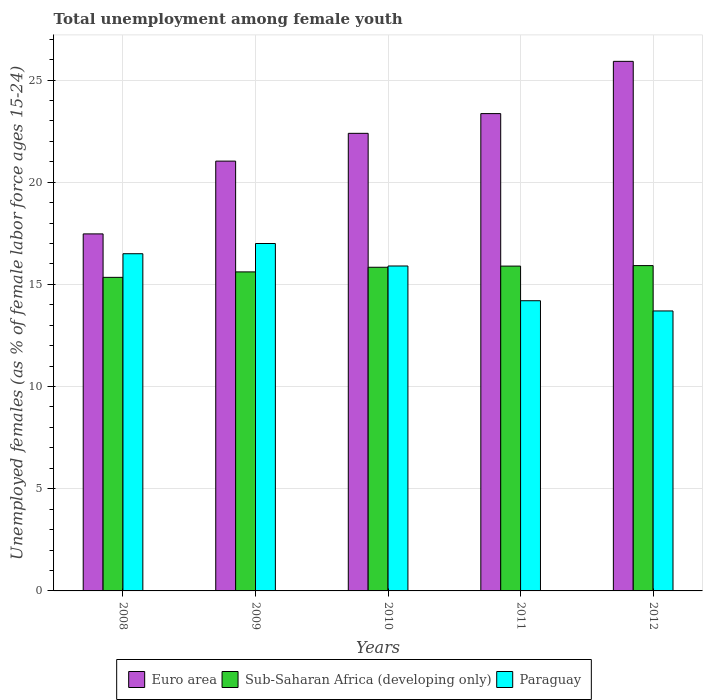What is the label of the 1st group of bars from the left?
Give a very brief answer. 2008. What is the percentage of unemployed females in in Paraguay in 2010?
Offer a terse response. 15.9. Across all years, what is the maximum percentage of unemployed females in in Paraguay?
Provide a short and direct response. 17. Across all years, what is the minimum percentage of unemployed females in in Paraguay?
Keep it short and to the point. 13.7. In which year was the percentage of unemployed females in in Euro area maximum?
Offer a very short reply. 2012. In which year was the percentage of unemployed females in in Sub-Saharan Africa (developing only) minimum?
Your response must be concise. 2008. What is the total percentage of unemployed females in in Sub-Saharan Africa (developing only) in the graph?
Your response must be concise. 78.61. What is the difference between the percentage of unemployed females in in Sub-Saharan Africa (developing only) in 2008 and that in 2010?
Keep it short and to the point. -0.49. What is the difference between the percentage of unemployed females in in Sub-Saharan Africa (developing only) in 2011 and the percentage of unemployed females in in Euro area in 2009?
Provide a short and direct response. -5.14. What is the average percentage of unemployed females in in Sub-Saharan Africa (developing only) per year?
Offer a very short reply. 15.72. In the year 2011, what is the difference between the percentage of unemployed females in in Paraguay and percentage of unemployed females in in Euro area?
Keep it short and to the point. -9.16. In how many years, is the percentage of unemployed females in in Euro area greater than 22 %?
Keep it short and to the point. 3. What is the ratio of the percentage of unemployed females in in Euro area in 2009 to that in 2011?
Provide a succinct answer. 0.9. Is the difference between the percentage of unemployed females in in Paraguay in 2008 and 2012 greater than the difference between the percentage of unemployed females in in Euro area in 2008 and 2012?
Keep it short and to the point. Yes. What is the difference between the highest and the lowest percentage of unemployed females in in Sub-Saharan Africa (developing only)?
Ensure brevity in your answer.  0.57. What does the 2nd bar from the right in 2010 represents?
Your answer should be compact. Sub-Saharan Africa (developing only). Are all the bars in the graph horizontal?
Give a very brief answer. No. What is the difference between two consecutive major ticks on the Y-axis?
Offer a very short reply. 5. How many legend labels are there?
Provide a succinct answer. 3. What is the title of the graph?
Offer a terse response. Total unemployment among female youth. Does "Philippines" appear as one of the legend labels in the graph?
Offer a very short reply. No. What is the label or title of the Y-axis?
Keep it short and to the point. Unemployed females (as % of female labor force ages 15-24). What is the Unemployed females (as % of female labor force ages 15-24) of Euro area in 2008?
Make the answer very short. 17.47. What is the Unemployed females (as % of female labor force ages 15-24) of Sub-Saharan Africa (developing only) in 2008?
Provide a succinct answer. 15.34. What is the Unemployed females (as % of female labor force ages 15-24) of Paraguay in 2008?
Your answer should be compact. 16.5. What is the Unemployed females (as % of female labor force ages 15-24) of Euro area in 2009?
Make the answer very short. 21.03. What is the Unemployed females (as % of female labor force ages 15-24) of Sub-Saharan Africa (developing only) in 2009?
Your answer should be very brief. 15.61. What is the Unemployed females (as % of female labor force ages 15-24) of Euro area in 2010?
Offer a very short reply. 22.39. What is the Unemployed females (as % of female labor force ages 15-24) of Sub-Saharan Africa (developing only) in 2010?
Offer a very short reply. 15.84. What is the Unemployed females (as % of female labor force ages 15-24) of Paraguay in 2010?
Your response must be concise. 15.9. What is the Unemployed females (as % of female labor force ages 15-24) of Euro area in 2011?
Provide a succinct answer. 23.36. What is the Unemployed females (as % of female labor force ages 15-24) in Sub-Saharan Africa (developing only) in 2011?
Ensure brevity in your answer.  15.89. What is the Unemployed females (as % of female labor force ages 15-24) in Paraguay in 2011?
Provide a short and direct response. 14.2. What is the Unemployed females (as % of female labor force ages 15-24) of Euro area in 2012?
Provide a succinct answer. 25.91. What is the Unemployed females (as % of female labor force ages 15-24) in Sub-Saharan Africa (developing only) in 2012?
Offer a terse response. 15.92. What is the Unemployed females (as % of female labor force ages 15-24) of Paraguay in 2012?
Make the answer very short. 13.7. Across all years, what is the maximum Unemployed females (as % of female labor force ages 15-24) in Euro area?
Give a very brief answer. 25.91. Across all years, what is the maximum Unemployed females (as % of female labor force ages 15-24) in Sub-Saharan Africa (developing only)?
Offer a terse response. 15.92. Across all years, what is the minimum Unemployed females (as % of female labor force ages 15-24) of Euro area?
Ensure brevity in your answer.  17.47. Across all years, what is the minimum Unemployed females (as % of female labor force ages 15-24) of Sub-Saharan Africa (developing only)?
Offer a terse response. 15.34. Across all years, what is the minimum Unemployed females (as % of female labor force ages 15-24) of Paraguay?
Offer a terse response. 13.7. What is the total Unemployed females (as % of female labor force ages 15-24) in Euro area in the graph?
Your answer should be very brief. 110.16. What is the total Unemployed females (as % of female labor force ages 15-24) in Sub-Saharan Africa (developing only) in the graph?
Give a very brief answer. 78.61. What is the total Unemployed females (as % of female labor force ages 15-24) in Paraguay in the graph?
Keep it short and to the point. 77.3. What is the difference between the Unemployed females (as % of female labor force ages 15-24) of Euro area in 2008 and that in 2009?
Offer a terse response. -3.56. What is the difference between the Unemployed females (as % of female labor force ages 15-24) of Sub-Saharan Africa (developing only) in 2008 and that in 2009?
Ensure brevity in your answer.  -0.27. What is the difference between the Unemployed females (as % of female labor force ages 15-24) of Paraguay in 2008 and that in 2009?
Offer a terse response. -0.5. What is the difference between the Unemployed females (as % of female labor force ages 15-24) in Euro area in 2008 and that in 2010?
Your answer should be compact. -4.92. What is the difference between the Unemployed females (as % of female labor force ages 15-24) in Sub-Saharan Africa (developing only) in 2008 and that in 2010?
Provide a short and direct response. -0.49. What is the difference between the Unemployed females (as % of female labor force ages 15-24) of Paraguay in 2008 and that in 2010?
Provide a short and direct response. 0.6. What is the difference between the Unemployed females (as % of female labor force ages 15-24) in Euro area in 2008 and that in 2011?
Ensure brevity in your answer.  -5.89. What is the difference between the Unemployed females (as % of female labor force ages 15-24) of Sub-Saharan Africa (developing only) in 2008 and that in 2011?
Your answer should be compact. -0.55. What is the difference between the Unemployed females (as % of female labor force ages 15-24) of Paraguay in 2008 and that in 2011?
Your answer should be compact. 2.3. What is the difference between the Unemployed females (as % of female labor force ages 15-24) of Euro area in 2008 and that in 2012?
Give a very brief answer. -8.44. What is the difference between the Unemployed females (as % of female labor force ages 15-24) in Sub-Saharan Africa (developing only) in 2008 and that in 2012?
Keep it short and to the point. -0.57. What is the difference between the Unemployed females (as % of female labor force ages 15-24) in Euro area in 2009 and that in 2010?
Keep it short and to the point. -1.36. What is the difference between the Unemployed females (as % of female labor force ages 15-24) in Sub-Saharan Africa (developing only) in 2009 and that in 2010?
Your answer should be compact. -0.23. What is the difference between the Unemployed females (as % of female labor force ages 15-24) in Euro area in 2009 and that in 2011?
Offer a terse response. -2.33. What is the difference between the Unemployed females (as % of female labor force ages 15-24) in Sub-Saharan Africa (developing only) in 2009 and that in 2011?
Provide a short and direct response. -0.28. What is the difference between the Unemployed females (as % of female labor force ages 15-24) of Paraguay in 2009 and that in 2011?
Offer a very short reply. 2.8. What is the difference between the Unemployed females (as % of female labor force ages 15-24) in Euro area in 2009 and that in 2012?
Provide a short and direct response. -4.88. What is the difference between the Unemployed females (as % of female labor force ages 15-24) of Sub-Saharan Africa (developing only) in 2009 and that in 2012?
Ensure brevity in your answer.  -0.31. What is the difference between the Unemployed females (as % of female labor force ages 15-24) in Euro area in 2010 and that in 2011?
Provide a short and direct response. -0.97. What is the difference between the Unemployed females (as % of female labor force ages 15-24) in Sub-Saharan Africa (developing only) in 2010 and that in 2011?
Give a very brief answer. -0.06. What is the difference between the Unemployed females (as % of female labor force ages 15-24) of Paraguay in 2010 and that in 2011?
Your answer should be very brief. 1.7. What is the difference between the Unemployed females (as % of female labor force ages 15-24) in Euro area in 2010 and that in 2012?
Ensure brevity in your answer.  -3.52. What is the difference between the Unemployed females (as % of female labor force ages 15-24) of Sub-Saharan Africa (developing only) in 2010 and that in 2012?
Make the answer very short. -0.08. What is the difference between the Unemployed females (as % of female labor force ages 15-24) of Euro area in 2011 and that in 2012?
Your answer should be very brief. -2.56. What is the difference between the Unemployed females (as % of female labor force ages 15-24) in Sub-Saharan Africa (developing only) in 2011 and that in 2012?
Provide a succinct answer. -0.02. What is the difference between the Unemployed females (as % of female labor force ages 15-24) in Paraguay in 2011 and that in 2012?
Your answer should be compact. 0.5. What is the difference between the Unemployed females (as % of female labor force ages 15-24) in Euro area in 2008 and the Unemployed females (as % of female labor force ages 15-24) in Sub-Saharan Africa (developing only) in 2009?
Ensure brevity in your answer.  1.86. What is the difference between the Unemployed females (as % of female labor force ages 15-24) in Euro area in 2008 and the Unemployed females (as % of female labor force ages 15-24) in Paraguay in 2009?
Offer a very short reply. 0.47. What is the difference between the Unemployed females (as % of female labor force ages 15-24) of Sub-Saharan Africa (developing only) in 2008 and the Unemployed females (as % of female labor force ages 15-24) of Paraguay in 2009?
Your response must be concise. -1.66. What is the difference between the Unemployed females (as % of female labor force ages 15-24) in Euro area in 2008 and the Unemployed females (as % of female labor force ages 15-24) in Sub-Saharan Africa (developing only) in 2010?
Your response must be concise. 1.63. What is the difference between the Unemployed females (as % of female labor force ages 15-24) in Euro area in 2008 and the Unemployed females (as % of female labor force ages 15-24) in Paraguay in 2010?
Make the answer very short. 1.57. What is the difference between the Unemployed females (as % of female labor force ages 15-24) in Sub-Saharan Africa (developing only) in 2008 and the Unemployed females (as % of female labor force ages 15-24) in Paraguay in 2010?
Provide a succinct answer. -0.56. What is the difference between the Unemployed females (as % of female labor force ages 15-24) in Euro area in 2008 and the Unemployed females (as % of female labor force ages 15-24) in Sub-Saharan Africa (developing only) in 2011?
Provide a short and direct response. 1.58. What is the difference between the Unemployed females (as % of female labor force ages 15-24) in Euro area in 2008 and the Unemployed females (as % of female labor force ages 15-24) in Paraguay in 2011?
Your response must be concise. 3.27. What is the difference between the Unemployed females (as % of female labor force ages 15-24) in Sub-Saharan Africa (developing only) in 2008 and the Unemployed females (as % of female labor force ages 15-24) in Paraguay in 2011?
Offer a terse response. 1.14. What is the difference between the Unemployed females (as % of female labor force ages 15-24) in Euro area in 2008 and the Unemployed females (as % of female labor force ages 15-24) in Sub-Saharan Africa (developing only) in 2012?
Your answer should be compact. 1.55. What is the difference between the Unemployed females (as % of female labor force ages 15-24) in Euro area in 2008 and the Unemployed females (as % of female labor force ages 15-24) in Paraguay in 2012?
Keep it short and to the point. 3.77. What is the difference between the Unemployed females (as % of female labor force ages 15-24) of Sub-Saharan Africa (developing only) in 2008 and the Unemployed females (as % of female labor force ages 15-24) of Paraguay in 2012?
Provide a succinct answer. 1.64. What is the difference between the Unemployed females (as % of female labor force ages 15-24) of Euro area in 2009 and the Unemployed females (as % of female labor force ages 15-24) of Sub-Saharan Africa (developing only) in 2010?
Your answer should be very brief. 5.19. What is the difference between the Unemployed females (as % of female labor force ages 15-24) in Euro area in 2009 and the Unemployed females (as % of female labor force ages 15-24) in Paraguay in 2010?
Provide a short and direct response. 5.13. What is the difference between the Unemployed females (as % of female labor force ages 15-24) of Sub-Saharan Africa (developing only) in 2009 and the Unemployed females (as % of female labor force ages 15-24) of Paraguay in 2010?
Ensure brevity in your answer.  -0.29. What is the difference between the Unemployed females (as % of female labor force ages 15-24) of Euro area in 2009 and the Unemployed females (as % of female labor force ages 15-24) of Sub-Saharan Africa (developing only) in 2011?
Keep it short and to the point. 5.14. What is the difference between the Unemployed females (as % of female labor force ages 15-24) in Euro area in 2009 and the Unemployed females (as % of female labor force ages 15-24) in Paraguay in 2011?
Offer a terse response. 6.83. What is the difference between the Unemployed females (as % of female labor force ages 15-24) in Sub-Saharan Africa (developing only) in 2009 and the Unemployed females (as % of female labor force ages 15-24) in Paraguay in 2011?
Ensure brevity in your answer.  1.41. What is the difference between the Unemployed females (as % of female labor force ages 15-24) in Euro area in 2009 and the Unemployed females (as % of female labor force ages 15-24) in Sub-Saharan Africa (developing only) in 2012?
Your response must be concise. 5.11. What is the difference between the Unemployed females (as % of female labor force ages 15-24) of Euro area in 2009 and the Unemployed females (as % of female labor force ages 15-24) of Paraguay in 2012?
Keep it short and to the point. 7.33. What is the difference between the Unemployed females (as % of female labor force ages 15-24) of Sub-Saharan Africa (developing only) in 2009 and the Unemployed females (as % of female labor force ages 15-24) of Paraguay in 2012?
Offer a terse response. 1.91. What is the difference between the Unemployed females (as % of female labor force ages 15-24) of Euro area in 2010 and the Unemployed females (as % of female labor force ages 15-24) of Sub-Saharan Africa (developing only) in 2011?
Your response must be concise. 6.5. What is the difference between the Unemployed females (as % of female labor force ages 15-24) in Euro area in 2010 and the Unemployed females (as % of female labor force ages 15-24) in Paraguay in 2011?
Provide a short and direct response. 8.19. What is the difference between the Unemployed females (as % of female labor force ages 15-24) in Sub-Saharan Africa (developing only) in 2010 and the Unemployed females (as % of female labor force ages 15-24) in Paraguay in 2011?
Provide a short and direct response. 1.64. What is the difference between the Unemployed females (as % of female labor force ages 15-24) in Euro area in 2010 and the Unemployed females (as % of female labor force ages 15-24) in Sub-Saharan Africa (developing only) in 2012?
Offer a very short reply. 6.47. What is the difference between the Unemployed females (as % of female labor force ages 15-24) of Euro area in 2010 and the Unemployed females (as % of female labor force ages 15-24) of Paraguay in 2012?
Make the answer very short. 8.69. What is the difference between the Unemployed females (as % of female labor force ages 15-24) of Sub-Saharan Africa (developing only) in 2010 and the Unemployed females (as % of female labor force ages 15-24) of Paraguay in 2012?
Your response must be concise. 2.14. What is the difference between the Unemployed females (as % of female labor force ages 15-24) of Euro area in 2011 and the Unemployed females (as % of female labor force ages 15-24) of Sub-Saharan Africa (developing only) in 2012?
Keep it short and to the point. 7.44. What is the difference between the Unemployed females (as % of female labor force ages 15-24) in Euro area in 2011 and the Unemployed females (as % of female labor force ages 15-24) in Paraguay in 2012?
Give a very brief answer. 9.66. What is the difference between the Unemployed females (as % of female labor force ages 15-24) of Sub-Saharan Africa (developing only) in 2011 and the Unemployed females (as % of female labor force ages 15-24) of Paraguay in 2012?
Make the answer very short. 2.19. What is the average Unemployed females (as % of female labor force ages 15-24) in Euro area per year?
Give a very brief answer. 22.03. What is the average Unemployed females (as % of female labor force ages 15-24) in Sub-Saharan Africa (developing only) per year?
Your answer should be very brief. 15.72. What is the average Unemployed females (as % of female labor force ages 15-24) in Paraguay per year?
Ensure brevity in your answer.  15.46. In the year 2008, what is the difference between the Unemployed females (as % of female labor force ages 15-24) of Euro area and Unemployed females (as % of female labor force ages 15-24) of Sub-Saharan Africa (developing only)?
Your answer should be compact. 2.13. In the year 2008, what is the difference between the Unemployed females (as % of female labor force ages 15-24) in Euro area and Unemployed females (as % of female labor force ages 15-24) in Paraguay?
Provide a succinct answer. 0.97. In the year 2008, what is the difference between the Unemployed females (as % of female labor force ages 15-24) in Sub-Saharan Africa (developing only) and Unemployed females (as % of female labor force ages 15-24) in Paraguay?
Keep it short and to the point. -1.16. In the year 2009, what is the difference between the Unemployed females (as % of female labor force ages 15-24) in Euro area and Unemployed females (as % of female labor force ages 15-24) in Sub-Saharan Africa (developing only)?
Your answer should be compact. 5.42. In the year 2009, what is the difference between the Unemployed females (as % of female labor force ages 15-24) of Euro area and Unemployed females (as % of female labor force ages 15-24) of Paraguay?
Offer a terse response. 4.03. In the year 2009, what is the difference between the Unemployed females (as % of female labor force ages 15-24) in Sub-Saharan Africa (developing only) and Unemployed females (as % of female labor force ages 15-24) in Paraguay?
Provide a short and direct response. -1.39. In the year 2010, what is the difference between the Unemployed females (as % of female labor force ages 15-24) of Euro area and Unemployed females (as % of female labor force ages 15-24) of Sub-Saharan Africa (developing only)?
Provide a succinct answer. 6.55. In the year 2010, what is the difference between the Unemployed females (as % of female labor force ages 15-24) of Euro area and Unemployed females (as % of female labor force ages 15-24) of Paraguay?
Give a very brief answer. 6.49. In the year 2010, what is the difference between the Unemployed females (as % of female labor force ages 15-24) of Sub-Saharan Africa (developing only) and Unemployed females (as % of female labor force ages 15-24) of Paraguay?
Provide a short and direct response. -0.06. In the year 2011, what is the difference between the Unemployed females (as % of female labor force ages 15-24) of Euro area and Unemployed females (as % of female labor force ages 15-24) of Sub-Saharan Africa (developing only)?
Your response must be concise. 7.46. In the year 2011, what is the difference between the Unemployed females (as % of female labor force ages 15-24) in Euro area and Unemployed females (as % of female labor force ages 15-24) in Paraguay?
Provide a succinct answer. 9.16. In the year 2011, what is the difference between the Unemployed females (as % of female labor force ages 15-24) of Sub-Saharan Africa (developing only) and Unemployed females (as % of female labor force ages 15-24) of Paraguay?
Your answer should be compact. 1.69. In the year 2012, what is the difference between the Unemployed females (as % of female labor force ages 15-24) of Euro area and Unemployed females (as % of female labor force ages 15-24) of Sub-Saharan Africa (developing only)?
Ensure brevity in your answer.  9.99. In the year 2012, what is the difference between the Unemployed females (as % of female labor force ages 15-24) of Euro area and Unemployed females (as % of female labor force ages 15-24) of Paraguay?
Your response must be concise. 12.21. In the year 2012, what is the difference between the Unemployed females (as % of female labor force ages 15-24) of Sub-Saharan Africa (developing only) and Unemployed females (as % of female labor force ages 15-24) of Paraguay?
Your response must be concise. 2.22. What is the ratio of the Unemployed females (as % of female labor force ages 15-24) of Euro area in 2008 to that in 2009?
Keep it short and to the point. 0.83. What is the ratio of the Unemployed females (as % of female labor force ages 15-24) in Sub-Saharan Africa (developing only) in 2008 to that in 2009?
Provide a succinct answer. 0.98. What is the ratio of the Unemployed females (as % of female labor force ages 15-24) in Paraguay in 2008 to that in 2009?
Offer a very short reply. 0.97. What is the ratio of the Unemployed females (as % of female labor force ages 15-24) in Euro area in 2008 to that in 2010?
Your response must be concise. 0.78. What is the ratio of the Unemployed females (as % of female labor force ages 15-24) in Sub-Saharan Africa (developing only) in 2008 to that in 2010?
Offer a very short reply. 0.97. What is the ratio of the Unemployed females (as % of female labor force ages 15-24) of Paraguay in 2008 to that in 2010?
Your answer should be compact. 1.04. What is the ratio of the Unemployed females (as % of female labor force ages 15-24) of Euro area in 2008 to that in 2011?
Your answer should be compact. 0.75. What is the ratio of the Unemployed females (as % of female labor force ages 15-24) of Sub-Saharan Africa (developing only) in 2008 to that in 2011?
Your answer should be compact. 0.97. What is the ratio of the Unemployed females (as % of female labor force ages 15-24) of Paraguay in 2008 to that in 2011?
Provide a succinct answer. 1.16. What is the ratio of the Unemployed females (as % of female labor force ages 15-24) in Euro area in 2008 to that in 2012?
Give a very brief answer. 0.67. What is the ratio of the Unemployed females (as % of female labor force ages 15-24) in Sub-Saharan Africa (developing only) in 2008 to that in 2012?
Provide a short and direct response. 0.96. What is the ratio of the Unemployed females (as % of female labor force ages 15-24) of Paraguay in 2008 to that in 2012?
Provide a short and direct response. 1.2. What is the ratio of the Unemployed females (as % of female labor force ages 15-24) in Euro area in 2009 to that in 2010?
Your answer should be compact. 0.94. What is the ratio of the Unemployed females (as % of female labor force ages 15-24) in Sub-Saharan Africa (developing only) in 2009 to that in 2010?
Your response must be concise. 0.99. What is the ratio of the Unemployed females (as % of female labor force ages 15-24) of Paraguay in 2009 to that in 2010?
Your response must be concise. 1.07. What is the ratio of the Unemployed females (as % of female labor force ages 15-24) of Euro area in 2009 to that in 2011?
Ensure brevity in your answer.  0.9. What is the ratio of the Unemployed females (as % of female labor force ages 15-24) in Sub-Saharan Africa (developing only) in 2009 to that in 2011?
Make the answer very short. 0.98. What is the ratio of the Unemployed females (as % of female labor force ages 15-24) in Paraguay in 2009 to that in 2011?
Your answer should be compact. 1.2. What is the ratio of the Unemployed females (as % of female labor force ages 15-24) in Euro area in 2009 to that in 2012?
Offer a very short reply. 0.81. What is the ratio of the Unemployed females (as % of female labor force ages 15-24) of Sub-Saharan Africa (developing only) in 2009 to that in 2012?
Offer a terse response. 0.98. What is the ratio of the Unemployed females (as % of female labor force ages 15-24) of Paraguay in 2009 to that in 2012?
Give a very brief answer. 1.24. What is the ratio of the Unemployed females (as % of female labor force ages 15-24) of Euro area in 2010 to that in 2011?
Your response must be concise. 0.96. What is the ratio of the Unemployed females (as % of female labor force ages 15-24) in Paraguay in 2010 to that in 2011?
Keep it short and to the point. 1.12. What is the ratio of the Unemployed females (as % of female labor force ages 15-24) of Euro area in 2010 to that in 2012?
Offer a very short reply. 0.86. What is the ratio of the Unemployed females (as % of female labor force ages 15-24) in Sub-Saharan Africa (developing only) in 2010 to that in 2012?
Your response must be concise. 0.99. What is the ratio of the Unemployed females (as % of female labor force ages 15-24) of Paraguay in 2010 to that in 2012?
Provide a short and direct response. 1.16. What is the ratio of the Unemployed females (as % of female labor force ages 15-24) in Euro area in 2011 to that in 2012?
Make the answer very short. 0.9. What is the ratio of the Unemployed females (as % of female labor force ages 15-24) of Sub-Saharan Africa (developing only) in 2011 to that in 2012?
Offer a very short reply. 1. What is the ratio of the Unemployed females (as % of female labor force ages 15-24) in Paraguay in 2011 to that in 2012?
Your answer should be compact. 1.04. What is the difference between the highest and the second highest Unemployed females (as % of female labor force ages 15-24) in Euro area?
Your response must be concise. 2.56. What is the difference between the highest and the second highest Unemployed females (as % of female labor force ages 15-24) of Sub-Saharan Africa (developing only)?
Keep it short and to the point. 0.02. What is the difference between the highest and the lowest Unemployed females (as % of female labor force ages 15-24) in Euro area?
Give a very brief answer. 8.44. What is the difference between the highest and the lowest Unemployed females (as % of female labor force ages 15-24) of Sub-Saharan Africa (developing only)?
Make the answer very short. 0.57. 